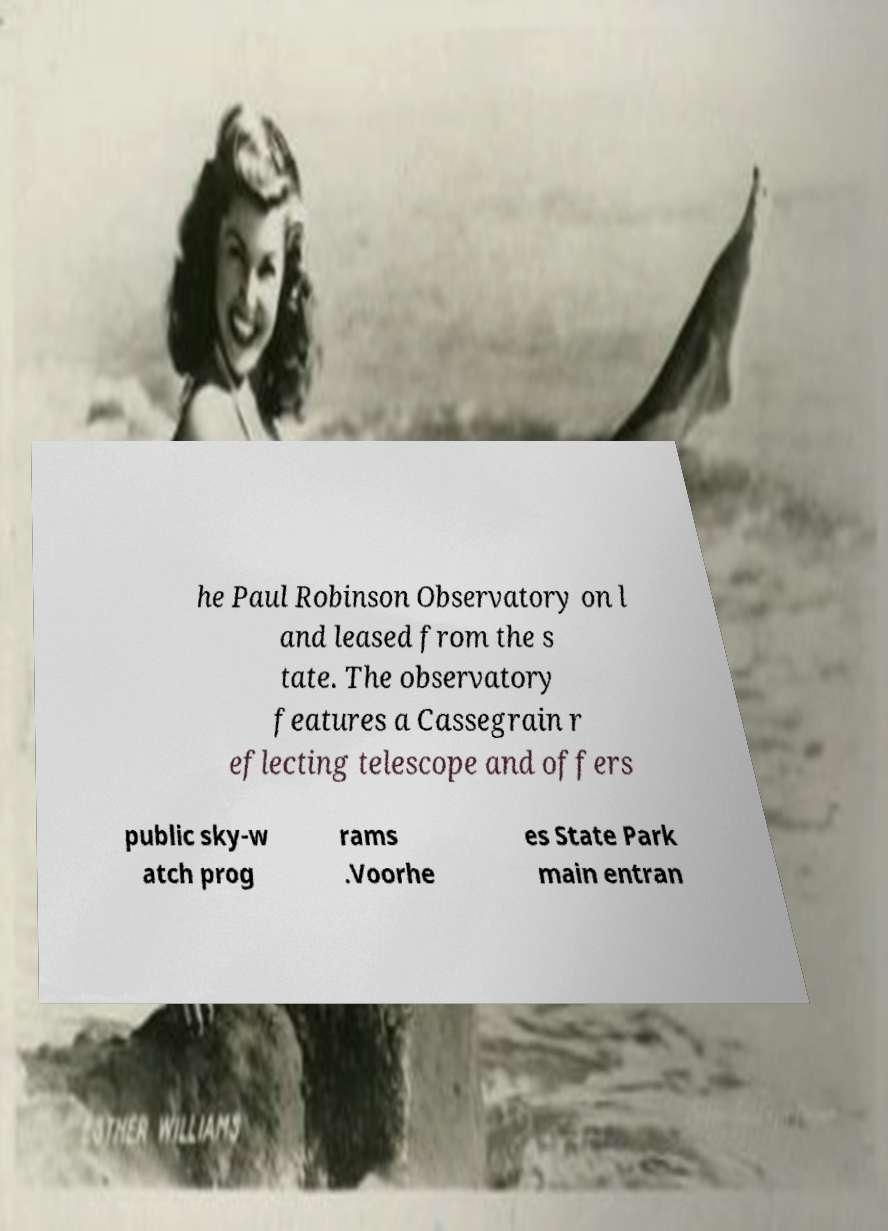Can you accurately transcribe the text from the provided image for me? he Paul Robinson Observatory on l and leased from the s tate. The observatory features a Cassegrain r eflecting telescope and offers public sky-w atch prog rams .Voorhe es State Park main entran 